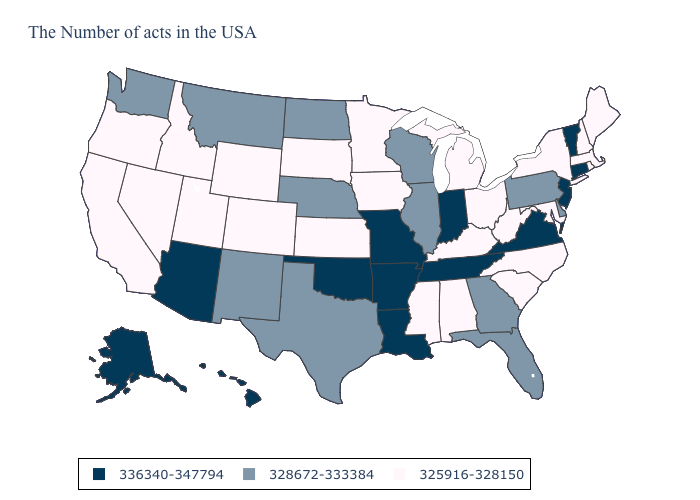Name the states that have a value in the range 328672-333384?
Short answer required. Delaware, Pennsylvania, Florida, Georgia, Wisconsin, Illinois, Nebraska, Texas, North Dakota, New Mexico, Montana, Washington. Among the states that border Kentucky , which have the highest value?
Quick response, please. Virginia, Indiana, Tennessee, Missouri. Does Delaware have a higher value than Ohio?
Concise answer only. Yes. Name the states that have a value in the range 328672-333384?
Keep it brief. Delaware, Pennsylvania, Florida, Georgia, Wisconsin, Illinois, Nebraska, Texas, North Dakota, New Mexico, Montana, Washington. What is the value of Massachusetts?
Give a very brief answer. 325916-328150. Does Illinois have the lowest value in the USA?
Write a very short answer. No. What is the value of South Dakota?
Write a very short answer. 325916-328150. How many symbols are there in the legend?
Write a very short answer. 3. What is the highest value in the West ?
Give a very brief answer. 336340-347794. Which states have the lowest value in the USA?
Short answer required. Maine, Massachusetts, Rhode Island, New Hampshire, New York, Maryland, North Carolina, South Carolina, West Virginia, Ohio, Michigan, Kentucky, Alabama, Mississippi, Minnesota, Iowa, Kansas, South Dakota, Wyoming, Colorado, Utah, Idaho, Nevada, California, Oregon. How many symbols are there in the legend?
Answer briefly. 3. What is the lowest value in states that border Pennsylvania?
Give a very brief answer. 325916-328150. What is the value of Connecticut?
Short answer required. 336340-347794. Name the states that have a value in the range 325916-328150?
Give a very brief answer. Maine, Massachusetts, Rhode Island, New Hampshire, New York, Maryland, North Carolina, South Carolina, West Virginia, Ohio, Michigan, Kentucky, Alabama, Mississippi, Minnesota, Iowa, Kansas, South Dakota, Wyoming, Colorado, Utah, Idaho, Nevada, California, Oregon. 